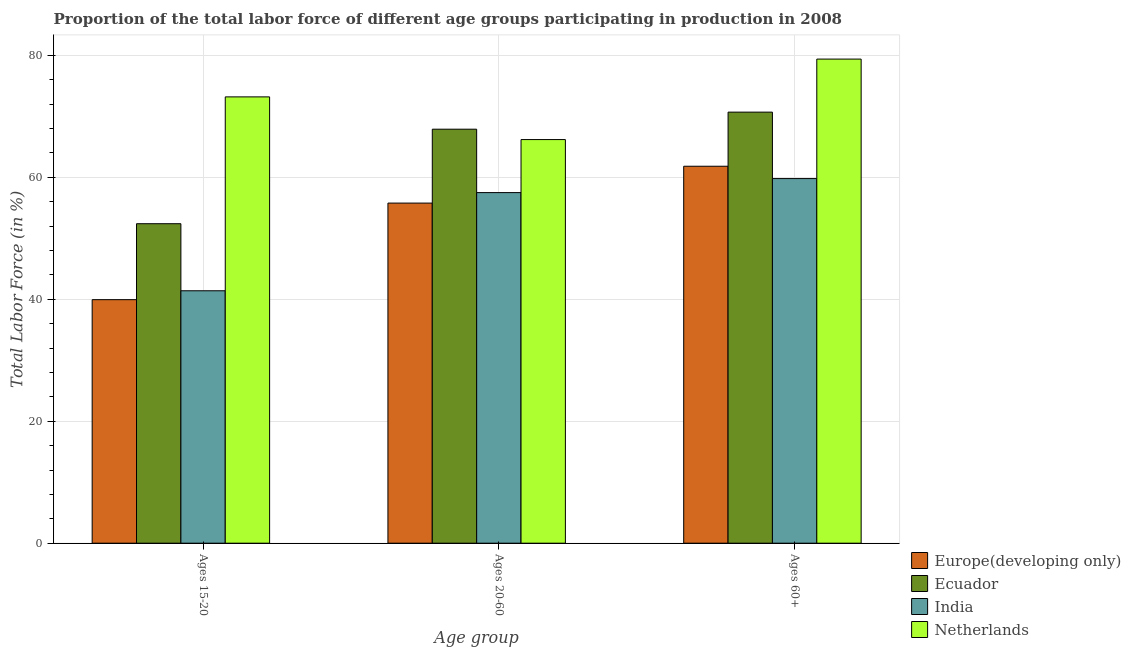What is the label of the 2nd group of bars from the left?
Ensure brevity in your answer.  Ages 20-60. What is the percentage of labor force within the age group 20-60 in Europe(developing only)?
Ensure brevity in your answer.  55.78. Across all countries, what is the maximum percentage of labor force within the age group 15-20?
Keep it short and to the point. 73.2. Across all countries, what is the minimum percentage of labor force above age 60?
Make the answer very short. 59.8. In which country was the percentage of labor force within the age group 15-20 maximum?
Provide a short and direct response. Netherlands. What is the total percentage of labor force above age 60 in the graph?
Give a very brief answer. 271.72. What is the difference between the percentage of labor force above age 60 in Europe(developing only) and that in Ecuador?
Offer a terse response. -8.88. What is the difference between the percentage of labor force above age 60 in Europe(developing only) and the percentage of labor force within the age group 15-20 in Netherlands?
Provide a short and direct response. -11.38. What is the average percentage of labor force above age 60 per country?
Ensure brevity in your answer.  67.93. What is the difference between the percentage of labor force within the age group 20-60 and percentage of labor force above age 60 in Netherlands?
Ensure brevity in your answer.  -13.2. What is the ratio of the percentage of labor force within the age group 20-60 in Europe(developing only) to that in Netherlands?
Keep it short and to the point. 0.84. Is the difference between the percentage of labor force within the age group 15-20 in Netherlands and Europe(developing only) greater than the difference between the percentage of labor force within the age group 20-60 in Netherlands and Europe(developing only)?
Make the answer very short. Yes. What is the difference between the highest and the second highest percentage of labor force within the age group 20-60?
Your answer should be very brief. 1.7. What is the difference between the highest and the lowest percentage of labor force within the age group 20-60?
Your answer should be compact. 12.12. In how many countries, is the percentage of labor force within the age group 20-60 greater than the average percentage of labor force within the age group 20-60 taken over all countries?
Ensure brevity in your answer.  2. What does the 3rd bar from the left in Ages 60+ represents?
Keep it short and to the point. India. Is it the case that in every country, the sum of the percentage of labor force within the age group 15-20 and percentage of labor force within the age group 20-60 is greater than the percentage of labor force above age 60?
Make the answer very short. Yes. How many bars are there?
Your response must be concise. 12. How many countries are there in the graph?
Your response must be concise. 4. What is the difference between two consecutive major ticks on the Y-axis?
Ensure brevity in your answer.  20. Are the values on the major ticks of Y-axis written in scientific E-notation?
Make the answer very short. No. Does the graph contain grids?
Ensure brevity in your answer.  Yes. How many legend labels are there?
Keep it short and to the point. 4. What is the title of the graph?
Keep it short and to the point. Proportion of the total labor force of different age groups participating in production in 2008. What is the label or title of the X-axis?
Give a very brief answer. Age group. What is the Total Labor Force (in %) of Europe(developing only) in Ages 15-20?
Your response must be concise. 39.94. What is the Total Labor Force (in %) of Ecuador in Ages 15-20?
Your response must be concise. 52.4. What is the Total Labor Force (in %) of India in Ages 15-20?
Your answer should be very brief. 41.4. What is the Total Labor Force (in %) of Netherlands in Ages 15-20?
Provide a short and direct response. 73.2. What is the Total Labor Force (in %) of Europe(developing only) in Ages 20-60?
Offer a very short reply. 55.78. What is the Total Labor Force (in %) of Ecuador in Ages 20-60?
Provide a succinct answer. 67.9. What is the Total Labor Force (in %) in India in Ages 20-60?
Make the answer very short. 57.5. What is the Total Labor Force (in %) of Netherlands in Ages 20-60?
Keep it short and to the point. 66.2. What is the Total Labor Force (in %) of Europe(developing only) in Ages 60+?
Your response must be concise. 61.82. What is the Total Labor Force (in %) in Ecuador in Ages 60+?
Offer a very short reply. 70.7. What is the Total Labor Force (in %) in India in Ages 60+?
Give a very brief answer. 59.8. What is the Total Labor Force (in %) of Netherlands in Ages 60+?
Your response must be concise. 79.4. Across all Age group, what is the maximum Total Labor Force (in %) in Europe(developing only)?
Ensure brevity in your answer.  61.82. Across all Age group, what is the maximum Total Labor Force (in %) of Ecuador?
Keep it short and to the point. 70.7. Across all Age group, what is the maximum Total Labor Force (in %) in India?
Make the answer very short. 59.8. Across all Age group, what is the maximum Total Labor Force (in %) in Netherlands?
Make the answer very short. 79.4. Across all Age group, what is the minimum Total Labor Force (in %) in Europe(developing only)?
Give a very brief answer. 39.94. Across all Age group, what is the minimum Total Labor Force (in %) in Ecuador?
Your answer should be compact. 52.4. Across all Age group, what is the minimum Total Labor Force (in %) in India?
Provide a short and direct response. 41.4. Across all Age group, what is the minimum Total Labor Force (in %) in Netherlands?
Your response must be concise. 66.2. What is the total Total Labor Force (in %) of Europe(developing only) in the graph?
Give a very brief answer. 157.55. What is the total Total Labor Force (in %) in Ecuador in the graph?
Offer a terse response. 191. What is the total Total Labor Force (in %) of India in the graph?
Make the answer very short. 158.7. What is the total Total Labor Force (in %) of Netherlands in the graph?
Offer a very short reply. 218.8. What is the difference between the Total Labor Force (in %) of Europe(developing only) in Ages 15-20 and that in Ages 20-60?
Your response must be concise. -15.84. What is the difference between the Total Labor Force (in %) of Ecuador in Ages 15-20 and that in Ages 20-60?
Keep it short and to the point. -15.5. What is the difference between the Total Labor Force (in %) in India in Ages 15-20 and that in Ages 20-60?
Give a very brief answer. -16.1. What is the difference between the Total Labor Force (in %) in Europe(developing only) in Ages 15-20 and that in Ages 60+?
Offer a very short reply. -21.88. What is the difference between the Total Labor Force (in %) of Ecuador in Ages 15-20 and that in Ages 60+?
Make the answer very short. -18.3. What is the difference between the Total Labor Force (in %) of India in Ages 15-20 and that in Ages 60+?
Your answer should be very brief. -18.4. What is the difference between the Total Labor Force (in %) in Europe(developing only) in Ages 20-60 and that in Ages 60+?
Your response must be concise. -6.04. What is the difference between the Total Labor Force (in %) of Netherlands in Ages 20-60 and that in Ages 60+?
Provide a short and direct response. -13.2. What is the difference between the Total Labor Force (in %) in Europe(developing only) in Ages 15-20 and the Total Labor Force (in %) in Ecuador in Ages 20-60?
Ensure brevity in your answer.  -27.96. What is the difference between the Total Labor Force (in %) of Europe(developing only) in Ages 15-20 and the Total Labor Force (in %) of India in Ages 20-60?
Offer a terse response. -17.56. What is the difference between the Total Labor Force (in %) of Europe(developing only) in Ages 15-20 and the Total Labor Force (in %) of Netherlands in Ages 20-60?
Ensure brevity in your answer.  -26.26. What is the difference between the Total Labor Force (in %) in Ecuador in Ages 15-20 and the Total Labor Force (in %) in India in Ages 20-60?
Make the answer very short. -5.1. What is the difference between the Total Labor Force (in %) of Ecuador in Ages 15-20 and the Total Labor Force (in %) of Netherlands in Ages 20-60?
Offer a very short reply. -13.8. What is the difference between the Total Labor Force (in %) in India in Ages 15-20 and the Total Labor Force (in %) in Netherlands in Ages 20-60?
Your response must be concise. -24.8. What is the difference between the Total Labor Force (in %) of Europe(developing only) in Ages 15-20 and the Total Labor Force (in %) of Ecuador in Ages 60+?
Provide a short and direct response. -30.76. What is the difference between the Total Labor Force (in %) of Europe(developing only) in Ages 15-20 and the Total Labor Force (in %) of India in Ages 60+?
Provide a succinct answer. -19.86. What is the difference between the Total Labor Force (in %) of Europe(developing only) in Ages 15-20 and the Total Labor Force (in %) of Netherlands in Ages 60+?
Keep it short and to the point. -39.46. What is the difference between the Total Labor Force (in %) of Ecuador in Ages 15-20 and the Total Labor Force (in %) of Netherlands in Ages 60+?
Ensure brevity in your answer.  -27. What is the difference between the Total Labor Force (in %) of India in Ages 15-20 and the Total Labor Force (in %) of Netherlands in Ages 60+?
Offer a terse response. -38. What is the difference between the Total Labor Force (in %) in Europe(developing only) in Ages 20-60 and the Total Labor Force (in %) in Ecuador in Ages 60+?
Ensure brevity in your answer.  -14.92. What is the difference between the Total Labor Force (in %) of Europe(developing only) in Ages 20-60 and the Total Labor Force (in %) of India in Ages 60+?
Offer a terse response. -4.02. What is the difference between the Total Labor Force (in %) in Europe(developing only) in Ages 20-60 and the Total Labor Force (in %) in Netherlands in Ages 60+?
Offer a terse response. -23.62. What is the difference between the Total Labor Force (in %) in Ecuador in Ages 20-60 and the Total Labor Force (in %) in Netherlands in Ages 60+?
Offer a very short reply. -11.5. What is the difference between the Total Labor Force (in %) of India in Ages 20-60 and the Total Labor Force (in %) of Netherlands in Ages 60+?
Keep it short and to the point. -21.9. What is the average Total Labor Force (in %) in Europe(developing only) per Age group?
Ensure brevity in your answer.  52.52. What is the average Total Labor Force (in %) of Ecuador per Age group?
Offer a terse response. 63.67. What is the average Total Labor Force (in %) of India per Age group?
Your answer should be compact. 52.9. What is the average Total Labor Force (in %) in Netherlands per Age group?
Provide a short and direct response. 72.93. What is the difference between the Total Labor Force (in %) in Europe(developing only) and Total Labor Force (in %) in Ecuador in Ages 15-20?
Ensure brevity in your answer.  -12.46. What is the difference between the Total Labor Force (in %) in Europe(developing only) and Total Labor Force (in %) in India in Ages 15-20?
Offer a very short reply. -1.46. What is the difference between the Total Labor Force (in %) in Europe(developing only) and Total Labor Force (in %) in Netherlands in Ages 15-20?
Your answer should be compact. -33.26. What is the difference between the Total Labor Force (in %) in Ecuador and Total Labor Force (in %) in Netherlands in Ages 15-20?
Make the answer very short. -20.8. What is the difference between the Total Labor Force (in %) in India and Total Labor Force (in %) in Netherlands in Ages 15-20?
Your answer should be very brief. -31.8. What is the difference between the Total Labor Force (in %) of Europe(developing only) and Total Labor Force (in %) of Ecuador in Ages 20-60?
Give a very brief answer. -12.12. What is the difference between the Total Labor Force (in %) of Europe(developing only) and Total Labor Force (in %) of India in Ages 20-60?
Offer a terse response. -1.72. What is the difference between the Total Labor Force (in %) in Europe(developing only) and Total Labor Force (in %) in Netherlands in Ages 20-60?
Your answer should be compact. -10.42. What is the difference between the Total Labor Force (in %) in Ecuador and Total Labor Force (in %) in India in Ages 20-60?
Your answer should be compact. 10.4. What is the difference between the Total Labor Force (in %) in Ecuador and Total Labor Force (in %) in Netherlands in Ages 20-60?
Your answer should be very brief. 1.7. What is the difference between the Total Labor Force (in %) of India and Total Labor Force (in %) of Netherlands in Ages 20-60?
Offer a very short reply. -8.7. What is the difference between the Total Labor Force (in %) of Europe(developing only) and Total Labor Force (in %) of Ecuador in Ages 60+?
Your response must be concise. -8.88. What is the difference between the Total Labor Force (in %) in Europe(developing only) and Total Labor Force (in %) in India in Ages 60+?
Keep it short and to the point. 2.02. What is the difference between the Total Labor Force (in %) of Europe(developing only) and Total Labor Force (in %) of Netherlands in Ages 60+?
Keep it short and to the point. -17.58. What is the difference between the Total Labor Force (in %) of India and Total Labor Force (in %) of Netherlands in Ages 60+?
Provide a short and direct response. -19.6. What is the ratio of the Total Labor Force (in %) in Europe(developing only) in Ages 15-20 to that in Ages 20-60?
Your answer should be very brief. 0.72. What is the ratio of the Total Labor Force (in %) of Ecuador in Ages 15-20 to that in Ages 20-60?
Offer a very short reply. 0.77. What is the ratio of the Total Labor Force (in %) in India in Ages 15-20 to that in Ages 20-60?
Provide a succinct answer. 0.72. What is the ratio of the Total Labor Force (in %) in Netherlands in Ages 15-20 to that in Ages 20-60?
Your response must be concise. 1.11. What is the ratio of the Total Labor Force (in %) of Europe(developing only) in Ages 15-20 to that in Ages 60+?
Make the answer very short. 0.65. What is the ratio of the Total Labor Force (in %) in Ecuador in Ages 15-20 to that in Ages 60+?
Your answer should be very brief. 0.74. What is the ratio of the Total Labor Force (in %) in India in Ages 15-20 to that in Ages 60+?
Offer a terse response. 0.69. What is the ratio of the Total Labor Force (in %) of Netherlands in Ages 15-20 to that in Ages 60+?
Make the answer very short. 0.92. What is the ratio of the Total Labor Force (in %) in Europe(developing only) in Ages 20-60 to that in Ages 60+?
Your answer should be very brief. 0.9. What is the ratio of the Total Labor Force (in %) of Ecuador in Ages 20-60 to that in Ages 60+?
Your answer should be very brief. 0.96. What is the ratio of the Total Labor Force (in %) of India in Ages 20-60 to that in Ages 60+?
Ensure brevity in your answer.  0.96. What is the ratio of the Total Labor Force (in %) in Netherlands in Ages 20-60 to that in Ages 60+?
Your answer should be compact. 0.83. What is the difference between the highest and the second highest Total Labor Force (in %) of Europe(developing only)?
Provide a succinct answer. 6.04. What is the difference between the highest and the second highest Total Labor Force (in %) of Netherlands?
Your response must be concise. 6.2. What is the difference between the highest and the lowest Total Labor Force (in %) in Europe(developing only)?
Make the answer very short. 21.88. What is the difference between the highest and the lowest Total Labor Force (in %) of Ecuador?
Provide a succinct answer. 18.3. What is the difference between the highest and the lowest Total Labor Force (in %) in Netherlands?
Your answer should be compact. 13.2. 